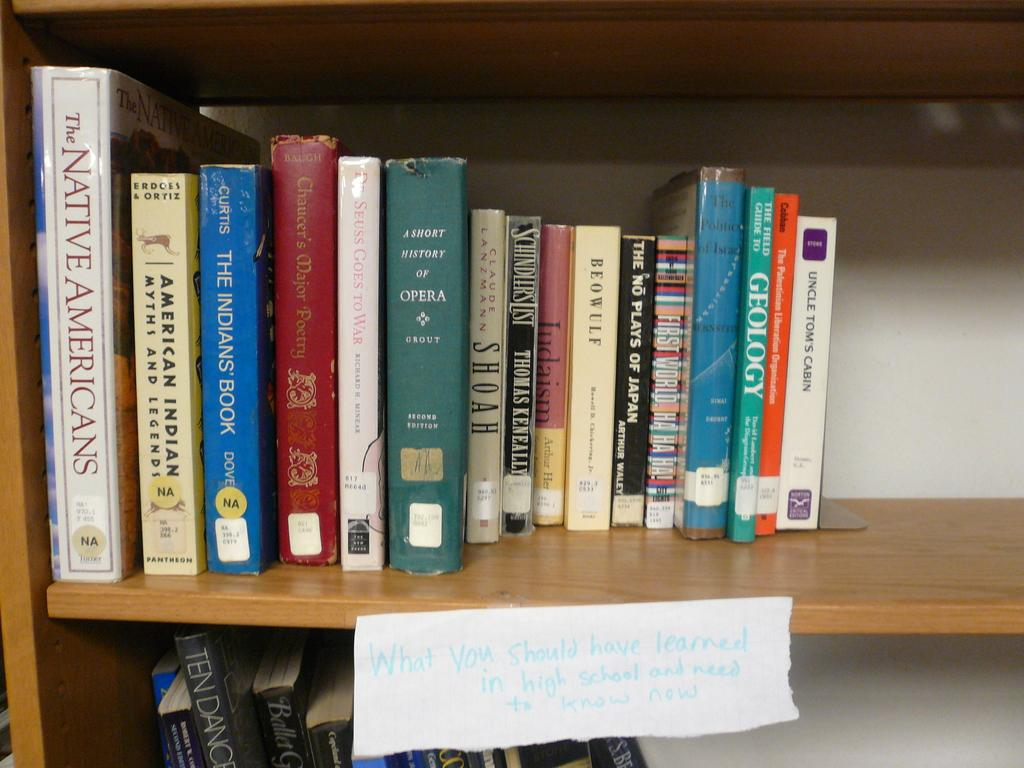<image>
Provide a brief description of the given image. A collection of a dozen or so books about Native Americans sits on a shelf. 